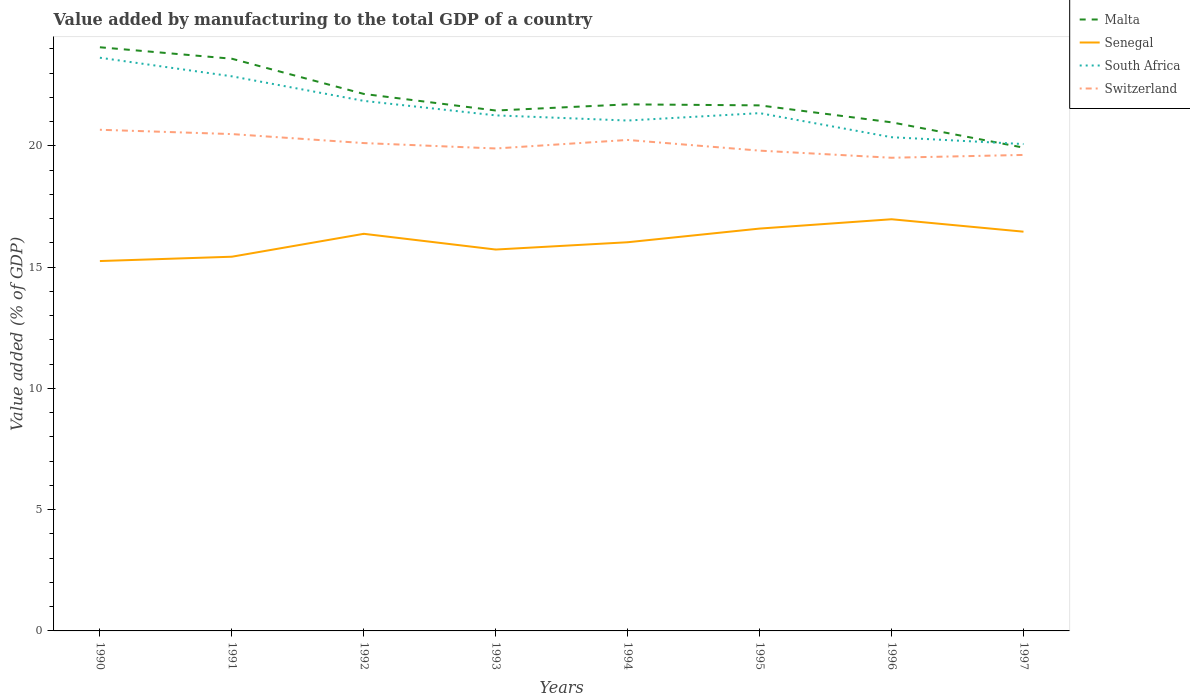How many different coloured lines are there?
Provide a short and direct response. 4. Does the line corresponding to Switzerland intersect with the line corresponding to Malta?
Provide a succinct answer. No. Is the number of lines equal to the number of legend labels?
Provide a succinct answer. Yes. Across all years, what is the maximum value added by manufacturing to the total GDP in Senegal?
Offer a very short reply. 15.25. What is the total value added by manufacturing to the total GDP in South Africa in the graph?
Your response must be concise. 1.01. What is the difference between the highest and the second highest value added by manufacturing to the total GDP in South Africa?
Offer a very short reply. 3.56. What is the difference between the highest and the lowest value added by manufacturing to the total GDP in Senegal?
Offer a very short reply. 4. How many lines are there?
Make the answer very short. 4. How many years are there in the graph?
Your answer should be compact. 8. What is the difference between two consecutive major ticks on the Y-axis?
Give a very brief answer. 5. Does the graph contain any zero values?
Provide a short and direct response. No. How are the legend labels stacked?
Your response must be concise. Vertical. What is the title of the graph?
Ensure brevity in your answer.  Value added by manufacturing to the total GDP of a country. What is the label or title of the Y-axis?
Provide a short and direct response. Value added (% of GDP). What is the Value added (% of GDP) of Malta in 1990?
Ensure brevity in your answer.  24.07. What is the Value added (% of GDP) in Senegal in 1990?
Offer a terse response. 15.25. What is the Value added (% of GDP) in South Africa in 1990?
Keep it short and to the point. 23.64. What is the Value added (% of GDP) of Switzerland in 1990?
Your answer should be compact. 20.67. What is the Value added (% of GDP) in Malta in 1991?
Your response must be concise. 23.6. What is the Value added (% of GDP) of Senegal in 1991?
Your answer should be compact. 15.43. What is the Value added (% of GDP) in South Africa in 1991?
Your answer should be very brief. 22.87. What is the Value added (% of GDP) in Switzerland in 1991?
Ensure brevity in your answer.  20.49. What is the Value added (% of GDP) of Malta in 1992?
Provide a succinct answer. 22.15. What is the Value added (% of GDP) of Senegal in 1992?
Your answer should be compact. 16.38. What is the Value added (% of GDP) of South Africa in 1992?
Your answer should be compact. 21.86. What is the Value added (% of GDP) in Switzerland in 1992?
Keep it short and to the point. 20.12. What is the Value added (% of GDP) of Malta in 1993?
Your answer should be very brief. 21.46. What is the Value added (% of GDP) of Senegal in 1993?
Provide a short and direct response. 15.73. What is the Value added (% of GDP) in South Africa in 1993?
Make the answer very short. 21.26. What is the Value added (% of GDP) of Switzerland in 1993?
Offer a very short reply. 19.9. What is the Value added (% of GDP) of Malta in 1994?
Offer a terse response. 21.72. What is the Value added (% of GDP) of Senegal in 1994?
Offer a very short reply. 16.03. What is the Value added (% of GDP) of South Africa in 1994?
Offer a terse response. 21.05. What is the Value added (% of GDP) in Switzerland in 1994?
Give a very brief answer. 20.25. What is the Value added (% of GDP) in Malta in 1995?
Provide a short and direct response. 21.67. What is the Value added (% of GDP) of Senegal in 1995?
Give a very brief answer. 16.59. What is the Value added (% of GDP) of South Africa in 1995?
Offer a very short reply. 21.35. What is the Value added (% of GDP) of Switzerland in 1995?
Offer a very short reply. 19.81. What is the Value added (% of GDP) of Malta in 1996?
Provide a succinct answer. 20.98. What is the Value added (% of GDP) in Senegal in 1996?
Your answer should be compact. 16.98. What is the Value added (% of GDP) of South Africa in 1996?
Your answer should be compact. 20.36. What is the Value added (% of GDP) of Switzerland in 1996?
Your answer should be compact. 19.51. What is the Value added (% of GDP) of Malta in 1997?
Your answer should be very brief. 19.93. What is the Value added (% of GDP) in Senegal in 1997?
Ensure brevity in your answer.  16.47. What is the Value added (% of GDP) in South Africa in 1997?
Give a very brief answer. 20.08. What is the Value added (% of GDP) in Switzerland in 1997?
Your answer should be very brief. 19.63. Across all years, what is the maximum Value added (% of GDP) in Malta?
Make the answer very short. 24.07. Across all years, what is the maximum Value added (% of GDP) in Senegal?
Your answer should be very brief. 16.98. Across all years, what is the maximum Value added (% of GDP) of South Africa?
Make the answer very short. 23.64. Across all years, what is the maximum Value added (% of GDP) of Switzerland?
Provide a succinct answer. 20.67. Across all years, what is the minimum Value added (% of GDP) in Malta?
Your response must be concise. 19.93. Across all years, what is the minimum Value added (% of GDP) of Senegal?
Your answer should be very brief. 15.25. Across all years, what is the minimum Value added (% of GDP) of South Africa?
Your response must be concise. 20.08. Across all years, what is the minimum Value added (% of GDP) in Switzerland?
Offer a very short reply. 19.51. What is the total Value added (% of GDP) of Malta in the graph?
Provide a succinct answer. 175.58. What is the total Value added (% of GDP) of Senegal in the graph?
Ensure brevity in your answer.  128.86. What is the total Value added (% of GDP) in South Africa in the graph?
Provide a succinct answer. 172.48. What is the total Value added (% of GDP) in Switzerland in the graph?
Ensure brevity in your answer.  160.38. What is the difference between the Value added (% of GDP) in Malta in 1990 and that in 1991?
Provide a short and direct response. 0.47. What is the difference between the Value added (% of GDP) of Senegal in 1990 and that in 1991?
Give a very brief answer. -0.18. What is the difference between the Value added (% of GDP) in South Africa in 1990 and that in 1991?
Give a very brief answer. 0.77. What is the difference between the Value added (% of GDP) of Switzerland in 1990 and that in 1991?
Keep it short and to the point. 0.18. What is the difference between the Value added (% of GDP) of Malta in 1990 and that in 1992?
Provide a succinct answer. 1.92. What is the difference between the Value added (% of GDP) of Senegal in 1990 and that in 1992?
Your answer should be compact. -1.12. What is the difference between the Value added (% of GDP) of South Africa in 1990 and that in 1992?
Your answer should be compact. 1.78. What is the difference between the Value added (% of GDP) of Switzerland in 1990 and that in 1992?
Offer a terse response. 0.55. What is the difference between the Value added (% of GDP) of Malta in 1990 and that in 1993?
Provide a succinct answer. 2.61. What is the difference between the Value added (% of GDP) of Senegal in 1990 and that in 1993?
Your answer should be very brief. -0.47. What is the difference between the Value added (% of GDP) of South Africa in 1990 and that in 1993?
Offer a terse response. 2.38. What is the difference between the Value added (% of GDP) in Switzerland in 1990 and that in 1993?
Offer a terse response. 0.77. What is the difference between the Value added (% of GDP) in Malta in 1990 and that in 1994?
Make the answer very short. 2.35. What is the difference between the Value added (% of GDP) in Senegal in 1990 and that in 1994?
Provide a succinct answer. -0.78. What is the difference between the Value added (% of GDP) of South Africa in 1990 and that in 1994?
Give a very brief answer. 2.59. What is the difference between the Value added (% of GDP) in Switzerland in 1990 and that in 1994?
Offer a very short reply. 0.42. What is the difference between the Value added (% of GDP) in Malta in 1990 and that in 1995?
Your answer should be compact. 2.4. What is the difference between the Value added (% of GDP) in Senegal in 1990 and that in 1995?
Your response must be concise. -1.34. What is the difference between the Value added (% of GDP) of South Africa in 1990 and that in 1995?
Make the answer very short. 2.29. What is the difference between the Value added (% of GDP) of Switzerland in 1990 and that in 1995?
Provide a succinct answer. 0.86. What is the difference between the Value added (% of GDP) of Malta in 1990 and that in 1996?
Offer a very short reply. 3.1. What is the difference between the Value added (% of GDP) in Senegal in 1990 and that in 1996?
Provide a short and direct response. -1.72. What is the difference between the Value added (% of GDP) in South Africa in 1990 and that in 1996?
Make the answer very short. 3.28. What is the difference between the Value added (% of GDP) in Switzerland in 1990 and that in 1996?
Provide a succinct answer. 1.15. What is the difference between the Value added (% of GDP) in Malta in 1990 and that in 1997?
Provide a succinct answer. 4.14. What is the difference between the Value added (% of GDP) in Senegal in 1990 and that in 1997?
Make the answer very short. -1.21. What is the difference between the Value added (% of GDP) of South Africa in 1990 and that in 1997?
Give a very brief answer. 3.56. What is the difference between the Value added (% of GDP) of Switzerland in 1990 and that in 1997?
Your answer should be compact. 1.04. What is the difference between the Value added (% of GDP) of Malta in 1991 and that in 1992?
Offer a very short reply. 1.45. What is the difference between the Value added (% of GDP) of Senegal in 1991 and that in 1992?
Your response must be concise. -0.94. What is the difference between the Value added (% of GDP) in South Africa in 1991 and that in 1992?
Your response must be concise. 1.01. What is the difference between the Value added (% of GDP) of Switzerland in 1991 and that in 1992?
Your answer should be compact. 0.37. What is the difference between the Value added (% of GDP) of Malta in 1991 and that in 1993?
Give a very brief answer. 2.14. What is the difference between the Value added (% of GDP) in Senegal in 1991 and that in 1993?
Ensure brevity in your answer.  -0.3. What is the difference between the Value added (% of GDP) of South Africa in 1991 and that in 1993?
Offer a terse response. 1.61. What is the difference between the Value added (% of GDP) in Switzerland in 1991 and that in 1993?
Ensure brevity in your answer.  0.59. What is the difference between the Value added (% of GDP) in Malta in 1991 and that in 1994?
Give a very brief answer. 1.88. What is the difference between the Value added (% of GDP) in Senegal in 1991 and that in 1994?
Provide a succinct answer. -0.6. What is the difference between the Value added (% of GDP) of South Africa in 1991 and that in 1994?
Ensure brevity in your answer.  1.82. What is the difference between the Value added (% of GDP) of Switzerland in 1991 and that in 1994?
Provide a succinct answer. 0.24. What is the difference between the Value added (% of GDP) of Malta in 1991 and that in 1995?
Make the answer very short. 1.92. What is the difference between the Value added (% of GDP) of Senegal in 1991 and that in 1995?
Give a very brief answer. -1.16. What is the difference between the Value added (% of GDP) in South Africa in 1991 and that in 1995?
Your answer should be compact. 1.52. What is the difference between the Value added (% of GDP) of Switzerland in 1991 and that in 1995?
Your answer should be compact. 0.68. What is the difference between the Value added (% of GDP) in Malta in 1991 and that in 1996?
Keep it short and to the point. 2.62. What is the difference between the Value added (% of GDP) of Senegal in 1991 and that in 1996?
Your answer should be very brief. -1.55. What is the difference between the Value added (% of GDP) in South Africa in 1991 and that in 1996?
Give a very brief answer. 2.51. What is the difference between the Value added (% of GDP) of Switzerland in 1991 and that in 1996?
Offer a very short reply. 0.98. What is the difference between the Value added (% of GDP) in Malta in 1991 and that in 1997?
Your answer should be compact. 3.67. What is the difference between the Value added (% of GDP) of Senegal in 1991 and that in 1997?
Make the answer very short. -1.03. What is the difference between the Value added (% of GDP) in South Africa in 1991 and that in 1997?
Provide a succinct answer. 2.79. What is the difference between the Value added (% of GDP) of Switzerland in 1991 and that in 1997?
Offer a very short reply. 0.86. What is the difference between the Value added (% of GDP) in Malta in 1992 and that in 1993?
Your answer should be compact. 0.68. What is the difference between the Value added (% of GDP) in Senegal in 1992 and that in 1993?
Your response must be concise. 0.65. What is the difference between the Value added (% of GDP) of South Africa in 1992 and that in 1993?
Provide a succinct answer. 0.6. What is the difference between the Value added (% of GDP) in Switzerland in 1992 and that in 1993?
Provide a short and direct response. 0.22. What is the difference between the Value added (% of GDP) of Malta in 1992 and that in 1994?
Provide a succinct answer. 0.43. What is the difference between the Value added (% of GDP) of Senegal in 1992 and that in 1994?
Your answer should be compact. 0.35. What is the difference between the Value added (% of GDP) in South Africa in 1992 and that in 1994?
Provide a succinct answer. 0.81. What is the difference between the Value added (% of GDP) of Switzerland in 1992 and that in 1994?
Your answer should be compact. -0.13. What is the difference between the Value added (% of GDP) of Malta in 1992 and that in 1995?
Your response must be concise. 0.47. What is the difference between the Value added (% of GDP) in Senegal in 1992 and that in 1995?
Keep it short and to the point. -0.22. What is the difference between the Value added (% of GDP) of South Africa in 1992 and that in 1995?
Keep it short and to the point. 0.51. What is the difference between the Value added (% of GDP) of Switzerland in 1992 and that in 1995?
Provide a succinct answer. 0.31. What is the difference between the Value added (% of GDP) of Malta in 1992 and that in 1996?
Provide a short and direct response. 1.17. What is the difference between the Value added (% of GDP) of Senegal in 1992 and that in 1996?
Give a very brief answer. -0.6. What is the difference between the Value added (% of GDP) of South Africa in 1992 and that in 1996?
Your answer should be compact. 1.5. What is the difference between the Value added (% of GDP) in Switzerland in 1992 and that in 1996?
Offer a very short reply. 0.61. What is the difference between the Value added (% of GDP) in Malta in 1992 and that in 1997?
Your answer should be very brief. 2.21. What is the difference between the Value added (% of GDP) in Senegal in 1992 and that in 1997?
Your answer should be very brief. -0.09. What is the difference between the Value added (% of GDP) in South Africa in 1992 and that in 1997?
Your answer should be very brief. 1.78. What is the difference between the Value added (% of GDP) in Switzerland in 1992 and that in 1997?
Provide a succinct answer. 0.49. What is the difference between the Value added (% of GDP) of Malta in 1993 and that in 1994?
Provide a short and direct response. -0.25. What is the difference between the Value added (% of GDP) in Senegal in 1993 and that in 1994?
Provide a short and direct response. -0.3. What is the difference between the Value added (% of GDP) of South Africa in 1993 and that in 1994?
Offer a terse response. 0.21. What is the difference between the Value added (% of GDP) of Switzerland in 1993 and that in 1994?
Give a very brief answer. -0.35. What is the difference between the Value added (% of GDP) of Malta in 1993 and that in 1995?
Ensure brevity in your answer.  -0.21. What is the difference between the Value added (% of GDP) in Senegal in 1993 and that in 1995?
Your answer should be compact. -0.86. What is the difference between the Value added (% of GDP) of South Africa in 1993 and that in 1995?
Your answer should be very brief. -0.09. What is the difference between the Value added (% of GDP) of Switzerland in 1993 and that in 1995?
Provide a short and direct response. 0.09. What is the difference between the Value added (% of GDP) in Malta in 1993 and that in 1996?
Provide a short and direct response. 0.49. What is the difference between the Value added (% of GDP) in Senegal in 1993 and that in 1996?
Your answer should be compact. -1.25. What is the difference between the Value added (% of GDP) of South Africa in 1993 and that in 1996?
Provide a succinct answer. 0.9. What is the difference between the Value added (% of GDP) in Switzerland in 1993 and that in 1996?
Provide a succinct answer. 0.38. What is the difference between the Value added (% of GDP) of Malta in 1993 and that in 1997?
Make the answer very short. 1.53. What is the difference between the Value added (% of GDP) in Senegal in 1993 and that in 1997?
Make the answer very short. -0.74. What is the difference between the Value added (% of GDP) of South Africa in 1993 and that in 1997?
Your answer should be very brief. 1.18. What is the difference between the Value added (% of GDP) in Switzerland in 1993 and that in 1997?
Keep it short and to the point. 0.27. What is the difference between the Value added (% of GDP) in Malta in 1994 and that in 1995?
Make the answer very short. 0.04. What is the difference between the Value added (% of GDP) of Senegal in 1994 and that in 1995?
Your answer should be compact. -0.56. What is the difference between the Value added (% of GDP) of South Africa in 1994 and that in 1995?
Offer a very short reply. -0.31. What is the difference between the Value added (% of GDP) in Switzerland in 1994 and that in 1995?
Offer a very short reply. 0.44. What is the difference between the Value added (% of GDP) of Malta in 1994 and that in 1996?
Your answer should be compact. 0.74. What is the difference between the Value added (% of GDP) in Senegal in 1994 and that in 1996?
Make the answer very short. -0.95. What is the difference between the Value added (% of GDP) in South Africa in 1994 and that in 1996?
Your answer should be very brief. 0.69. What is the difference between the Value added (% of GDP) of Switzerland in 1994 and that in 1996?
Offer a very short reply. 0.73. What is the difference between the Value added (% of GDP) in Malta in 1994 and that in 1997?
Give a very brief answer. 1.78. What is the difference between the Value added (% of GDP) in Senegal in 1994 and that in 1997?
Offer a very short reply. -0.44. What is the difference between the Value added (% of GDP) of South Africa in 1994 and that in 1997?
Your response must be concise. 0.97. What is the difference between the Value added (% of GDP) of Switzerland in 1994 and that in 1997?
Your answer should be very brief. 0.62. What is the difference between the Value added (% of GDP) of Malta in 1995 and that in 1996?
Offer a terse response. 0.7. What is the difference between the Value added (% of GDP) in Senegal in 1995 and that in 1996?
Your answer should be very brief. -0.38. What is the difference between the Value added (% of GDP) in South Africa in 1995 and that in 1996?
Provide a short and direct response. 0.99. What is the difference between the Value added (% of GDP) in Switzerland in 1995 and that in 1996?
Ensure brevity in your answer.  0.29. What is the difference between the Value added (% of GDP) in Malta in 1995 and that in 1997?
Your response must be concise. 1.74. What is the difference between the Value added (% of GDP) of Senegal in 1995 and that in 1997?
Make the answer very short. 0.13. What is the difference between the Value added (% of GDP) in South Africa in 1995 and that in 1997?
Offer a very short reply. 1.28. What is the difference between the Value added (% of GDP) of Switzerland in 1995 and that in 1997?
Offer a terse response. 0.18. What is the difference between the Value added (% of GDP) of Malta in 1996 and that in 1997?
Your answer should be very brief. 1.04. What is the difference between the Value added (% of GDP) in Senegal in 1996 and that in 1997?
Ensure brevity in your answer.  0.51. What is the difference between the Value added (% of GDP) in South Africa in 1996 and that in 1997?
Keep it short and to the point. 0.28. What is the difference between the Value added (% of GDP) in Switzerland in 1996 and that in 1997?
Make the answer very short. -0.12. What is the difference between the Value added (% of GDP) in Malta in 1990 and the Value added (% of GDP) in Senegal in 1991?
Offer a very short reply. 8.64. What is the difference between the Value added (% of GDP) in Malta in 1990 and the Value added (% of GDP) in South Africa in 1991?
Provide a short and direct response. 1.2. What is the difference between the Value added (% of GDP) in Malta in 1990 and the Value added (% of GDP) in Switzerland in 1991?
Ensure brevity in your answer.  3.58. What is the difference between the Value added (% of GDP) in Senegal in 1990 and the Value added (% of GDP) in South Africa in 1991?
Your answer should be compact. -7.62. What is the difference between the Value added (% of GDP) in Senegal in 1990 and the Value added (% of GDP) in Switzerland in 1991?
Your response must be concise. -5.24. What is the difference between the Value added (% of GDP) in South Africa in 1990 and the Value added (% of GDP) in Switzerland in 1991?
Offer a very short reply. 3.15. What is the difference between the Value added (% of GDP) in Malta in 1990 and the Value added (% of GDP) in Senegal in 1992?
Your answer should be compact. 7.69. What is the difference between the Value added (% of GDP) in Malta in 1990 and the Value added (% of GDP) in South Africa in 1992?
Provide a succinct answer. 2.21. What is the difference between the Value added (% of GDP) in Malta in 1990 and the Value added (% of GDP) in Switzerland in 1992?
Your answer should be very brief. 3.95. What is the difference between the Value added (% of GDP) of Senegal in 1990 and the Value added (% of GDP) of South Africa in 1992?
Keep it short and to the point. -6.61. What is the difference between the Value added (% of GDP) in Senegal in 1990 and the Value added (% of GDP) in Switzerland in 1992?
Your answer should be compact. -4.87. What is the difference between the Value added (% of GDP) in South Africa in 1990 and the Value added (% of GDP) in Switzerland in 1992?
Provide a succinct answer. 3.52. What is the difference between the Value added (% of GDP) of Malta in 1990 and the Value added (% of GDP) of Senegal in 1993?
Your answer should be compact. 8.34. What is the difference between the Value added (% of GDP) in Malta in 1990 and the Value added (% of GDP) in South Africa in 1993?
Make the answer very short. 2.81. What is the difference between the Value added (% of GDP) of Malta in 1990 and the Value added (% of GDP) of Switzerland in 1993?
Make the answer very short. 4.17. What is the difference between the Value added (% of GDP) of Senegal in 1990 and the Value added (% of GDP) of South Africa in 1993?
Offer a terse response. -6.01. What is the difference between the Value added (% of GDP) in Senegal in 1990 and the Value added (% of GDP) in Switzerland in 1993?
Ensure brevity in your answer.  -4.64. What is the difference between the Value added (% of GDP) in South Africa in 1990 and the Value added (% of GDP) in Switzerland in 1993?
Provide a succinct answer. 3.74. What is the difference between the Value added (% of GDP) in Malta in 1990 and the Value added (% of GDP) in Senegal in 1994?
Give a very brief answer. 8.04. What is the difference between the Value added (% of GDP) of Malta in 1990 and the Value added (% of GDP) of South Africa in 1994?
Your response must be concise. 3.02. What is the difference between the Value added (% of GDP) of Malta in 1990 and the Value added (% of GDP) of Switzerland in 1994?
Give a very brief answer. 3.82. What is the difference between the Value added (% of GDP) in Senegal in 1990 and the Value added (% of GDP) in South Africa in 1994?
Provide a succinct answer. -5.79. What is the difference between the Value added (% of GDP) in Senegal in 1990 and the Value added (% of GDP) in Switzerland in 1994?
Give a very brief answer. -4.99. What is the difference between the Value added (% of GDP) in South Africa in 1990 and the Value added (% of GDP) in Switzerland in 1994?
Offer a very short reply. 3.39. What is the difference between the Value added (% of GDP) in Malta in 1990 and the Value added (% of GDP) in Senegal in 1995?
Your answer should be very brief. 7.48. What is the difference between the Value added (% of GDP) in Malta in 1990 and the Value added (% of GDP) in South Africa in 1995?
Give a very brief answer. 2.72. What is the difference between the Value added (% of GDP) in Malta in 1990 and the Value added (% of GDP) in Switzerland in 1995?
Offer a terse response. 4.26. What is the difference between the Value added (% of GDP) in Senegal in 1990 and the Value added (% of GDP) in South Africa in 1995?
Give a very brief answer. -6.1. What is the difference between the Value added (% of GDP) in Senegal in 1990 and the Value added (% of GDP) in Switzerland in 1995?
Your response must be concise. -4.55. What is the difference between the Value added (% of GDP) of South Africa in 1990 and the Value added (% of GDP) of Switzerland in 1995?
Ensure brevity in your answer.  3.83. What is the difference between the Value added (% of GDP) in Malta in 1990 and the Value added (% of GDP) in Senegal in 1996?
Ensure brevity in your answer.  7.09. What is the difference between the Value added (% of GDP) in Malta in 1990 and the Value added (% of GDP) in South Africa in 1996?
Your answer should be very brief. 3.71. What is the difference between the Value added (% of GDP) in Malta in 1990 and the Value added (% of GDP) in Switzerland in 1996?
Offer a very short reply. 4.56. What is the difference between the Value added (% of GDP) of Senegal in 1990 and the Value added (% of GDP) of South Africa in 1996?
Give a very brief answer. -5.11. What is the difference between the Value added (% of GDP) of Senegal in 1990 and the Value added (% of GDP) of Switzerland in 1996?
Make the answer very short. -4.26. What is the difference between the Value added (% of GDP) in South Africa in 1990 and the Value added (% of GDP) in Switzerland in 1996?
Ensure brevity in your answer.  4.13. What is the difference between the Value added (% of GDP) of Malta in 1990 and the Value added (% of GDP) of Senegal in 1997?
Your response must be concise. 7.61. What is the difference between the Value added (% of GDP) in Malta in 1990 and the Value added (% of GDP) in South Africa in 1997?
Give a very brief answer. 3.99. What is the difference between the Value added (% of GDP) of Malta in 1990 and the Value added (% of GDP) of Switzerland in 1997?
Your response must be concise. 4.44. What is the difference between the Value added (% of GDP) in Senegal in 1990 and the Value added (% of GDP) in South Africa in 1997?
Ensure brevity in your answer.  -4.83. What is the difference between the Value added (% of GDP) in Senegal in 1990 and the Value added (% of GDP) in Switzerland in 1997?
Your answer should be compact. -4.38. What is the difference between the Value added (% of GDP) in South Africa in 1990 and the Value added (% of GDP) in Switzerland in 1997?
Ensure brevity in your answer.  4.01. What is the difference between the Value added (% of GDP) in Malta in 1991 and the Value added (% of GDP) in Senegal in 1992?
Provide a short and direct response. 7.22. What is the difference between the Value added (% of GDP) in Malta in 1991 and the Value added (% of GDP) in South Africa in 1992?
Your response must be concise. 1.74. What is the difference between the Value added (% of GDP) of Malta in 1991 and the Value added (% of GDP) of Switzerland in 1992?
Provide a short and direct response. 3.48. What is the difference between the Value added (% of GDP) of Senegal in 1991 and the Value added (% of GDP) of South Africa in 1992?
Give a very brief answer. -6.43. What is the difference between the Value added (% of GDP) of Senegal in 1991 and the Value added (% of GDP) of Switzerland in 1992?
Provide a succinct answer. -4.69. What is the difference between the Value added (% of GDP) in South Africa in 1991 and the Value added (% of GDP) in Switzerland in 1992?
Make the answer very short. 2.75. What is the difference between the Value added (% of GDP) in Malta in 1991 and the Value added (% of GDP) in Senegal in 1993?
Your answer should be compact. 7.87. What is the difference between the Value added (% of GDP) in Malta in 1991 and the Value added (% of GDP) in South Africa in 1993?
Offer a very short reply. 2.34. What is the difference between the Value added (% of GDP) of Malta in 1991 and the Value added (% of GDP) of Switzerland in 1993?
Make the answer very short. 3.7. What is the difference between the Value added (% of GDP) in Senegal in 1991 and the Value added (% of GDP) in South Africa in 1993?
Your response must be concise. -5.83. What is the difference between the Value added (% of GDP) of Senegal in 1991 and the Value added (% of GDP) of Switzerland in 1993?
Make the answer very short. -4.46. What is the difference between the Value added (% of GDP) of South Africa in 1991 and the Value added (% of GDP) of Switzerland in 1993?
Ensure brevity in your answer.  2.98. What is the difference between the Value added (% of GDP) in Malta in 1991 and the Value added (% of GDP) in Senegal in 1994?
Your answer should be compact. 7.57. What is the difference between the Value added (% of GDP) in Malta in 1991 and the Value added (% of GDP) in South Africa in 1994?
Keep it short and to the point. 2.55. What is the difference between the Value added (% of GDP) of Malta in 1991 and the Value added (% of GDP) of Switzerland in 1994?
Your answer should be compact. 3.35. What is the difference between the Value added (% of GDP) in Senegal in 1991 and the Value added (% of GDP) in South Africa in 1994?
Ensure brevity in your answer.  -5.62. What is the difference between the Value added (% of GDP) of Senegal in 1991 and the Value added (% of GDP) of Switzerland in 1994?
Offer a very short reply. -4.82. What is the difference between the Value added (% of GDP) of South Africa in 1991 and the Value added (% of GDP) of Switzerland in 1994?
Provide a succinct answer. 2.62. What is the difference between the Value added (% of GDP) in Malta in 1991 and the Value added (% of GDP) in Senegal in 1995?
Provide a succinct answer. 7.01. What is the difference between the Value added (% of GDP) of Malta in 1991 and the Value added (% of GDP) of South Africa in 1995?
Keep it short and to the point. 2.24. What is the difference between the Value added (% of GDP) in Malta in 1991 and the Value added (% of GDP) in Switzerland in 1995?
Provide a short and direct response. 3.79. What is the difference between the Value added (% of GDP) in Senegal in 1991 and the Value added (% of GDP) in South Africa in 1995?
Ensure brevity in your answer.  -5.92. What is the difference between the Value added (% of GDP) in Senegal in 1991 and the Value added (% of GDP) in Switzerland in 1995?
Your answer should be compact. -4.37. What is the difference between the Value added (% of GDP) of South Africa in 1991 and the Value added (% of GDP) of Switzerland in 1995?
Provide a short and direct response. 3.07. What is the difference between the Value added (% of GDP) in Malta in 1991 and the Value added (% of GDP) in Senegal in 1996?
Offer a terse response. 6.62. What is the difference between the Value added (% of GDP) of Malta in 1991 and the Value added (% of GDP) of South Africa in 1996?
Keep it short and to the point. 3.24. What is the difference between the Value added (% of GDP) in Malta in 1991 and the Value added (% of GDP) in Switzerland in 1996?
Ensure brevity in your answer.  4.08. What is the difference between the Value added (% of GDP) of Senegal in 1991 and the Value added (% of GDP) of South Africa in 1996?
Your answer should be very brief. -4.93. What is the difference between the Value added (% of GDP) of Senegal in 1991 and the Value added (% of GDP) of Switzerland in 1996?
Keep it short and to the point. -4.08. What is the difference between the Value added (% of GDP) in South Africa in 1991 and the Value added (% of GDP) in Switzerland in 1996?
Your response must be concise. 3.36. What is the difference between the Value added (% of GDP) of Malta in 1991 and the Value added (% of GDP) of Senegal in 1997?
Keep it short and to the point. 7.13. What is the difference between the Value added (% of GDP) in Malta in 1991 and the Value added (% of GDP) in South Africa in 1997?
Your answer should be compact. 3.52. What is the difference between the Value added (% of GDP) in Malta in 1991 and the Value added (% of GDP) in Switzerland in 1997?
Your answer should be very brief. 3.97. What is the difference between the Value added (% of GDP) of Senegal in 1991 and the Value added (% of GDP) of South Africa in 1997?
Your answer should be very brief. -4.65. What is the difference between the Value added (% of GDP) of Senegal in 1991 and the Value added (% of GDP) of Switzerland in 1997?
Keep it short and to the point. -4.2. What is the difference between the Value added (% of GDP) of South Africa in 1991 and the Value added (% of GDP) of Switzerland in 1997?
Your answer should be compact. 3.24. What is the difference between the Value added (% of GDP) in Malta in 1992 and the Value added (% of GDP) in Senegal in 1993?
Ensure brevity in your answer.  6.42. What is the difference between the Value added (% of GDP) in Malta in 1992 and the Value added (% of GDP) in South Africa in 1993?
Give a very brief answer. 0.88. What is the difference between the Value added (% of GDP) in Malta in 1992 and the Value added (% of GDP) in Switzerland in 1993?
Keep it short and to the point. 2.25. What is the difference between the Value added (% of GDP) in Senegal in 1992 and the Value added (% of GDP) in South Africa in 1993?
Provide a short and direct response. -4.88. What is the difference between the Value added (% of GDP) in Senegal in 1992 and the Value added (% of GDP) in Switzerland in 1993?
Offer a very short reply. -3.52. What is the difference between the Value added (% of GDP) in South Africa in 1992 and the Value added (% of GDP) in Switzerland in 1993?
Make the answer very short. 1.96. What is the difference between the Value added (% of GDP) in Malta in 1992 and the Value added (% of GDP) in Senegal in 1994?
Ensure brevity in your answer.  6.12. What is the difference between the Value added (% of GDP) of Malta in 1992 and the Value added (% of GDP) of South Africa in 1994?
Provide a succinct answer. 1.1. What is the difference between the Value added (% of GDP) in Malta in 1992 and the Value added (% of GDP) in Switzerland in 1994?
Your answer should be compact. 1.9. What is the difference between the Value added (% of GDP) in Senegal in 1992 and the Value added (% of GDP) in South Africa in 1994?
Your answer should be compact. -4.67. What is the difference between the Value added (% of GDP) of Senegal in 1992 and the Value added (% of GDP) of Switzerland in 1994?
Offer a very short reply. -3.87. What is the difference between the Value added (% of GDP) in South Africa in 1992 and the Value added (% of GDP) in Switzerland in 1994?
Make the answer very short. 1.61. What is the difference between the Value added (% of GDP) in Malta in 1992 and the Value added (% of GDP) in Senegal in 1995?
Your response must be concise. 5.55. What is the difference between the Value added (% of GDP) of Malta in 1992 and the Value added (% of GDP) of South Africa in 1995?
Provide a short and direct response. 0.79. What is the difference between the Value added (% of GDP) of Malta in 1992 and the Value added (% of GDP) of Switzerland in 1995?
Provide a succinct answer. 2.34. What is the difference between the Value added (% of GDP) in Senegal in 1992 and the Value added (% of GDP) in South Africa in 1995?
Make the answer very short. -4.98. What is the difference between the Value added (% of GDP) in Senegal in 1992 and the Value added (% of GDP) in Switzerland in 1995?
Ensure brevity in your answer.  -3.43. What is the difference between the Value added (% of GDP) of South Africa in 1992 and the Value added (% of GDP) of Switzerland in 1995?
Ensure brevity in your answer.  2.05. What is the difference between the Value added (% of GDP) in Malta in 1992 and the Value added (% of GDP) in Senegal in 1996?
Offer a terse response. 5.17. What is the difference between the Value added (% of GDP) of Malta in 1992 and the Value added (% of GDP) of South Africa in 1996?
Give a very brief answer. 1.79. What is the difference between the Value added (% of GDP) of Malta in 1992 and the Value added (% of GDP) of Switzerland in 1996?
Offer a terse response. 2.63. What is the difference between the Value added (% of GDP) in Senegal in 1992 and the Value added (% of GDP) in South Africa in 1996?
Provide a short and direct response. -3.98. What is the difference between the Value added (% of GDP) of Senegal in 1992 and the Value added (% of GDP) of Switzerland in 1996?
Offer a terse response. -3.14. What is the difference between the Value added (% of GDP) in South Africa in 1992 and the Value added (% of GDP) in Switzerland in 1996?
Your answer should be very brief. 2.35. What is the difference between the Value added (% of GDP) in Malta in 1992 and the Value added (% of GDP) in Senegal in 1997?
Provide a succinct answer. 5.68. What is the difference between the Value added (% of GDP) in Malta in 1992 and the Value added (% of GDP) in South Africa in 1997?
Offer a terse response. 2.07. What is the difference between the Value added (% of GDP) of Malta in 1992 and the Value added (% of GDP) of Switzerland in 1997?
Make the answer very short. 2.52. What is the difference between the Value added (% of GDP) in Senegal in 1992 and the Value added (% of GDP) in South Africa in 1997?
Give a very brief answer. -3.7. What is the difference between the Value added (% of GDP) of Senegal in 1992 and the Value added (% of GDP) of Switzerland in 1997?
Your response must be concise. -3.25. What is the difference between the Value added (% of GDP) of South Africa in 1992 and the Value added (% of GDP) of Switzerland in 1997?
Provide a succinct answer. 2.23. What is the difference between the Value added (% of GDP) in Malta in 1993 and the Value added (% of GDP) in Senegal in 1994?
Offer a terse response. 5.43. What is the difference between the Value added (% of GDP) of Malta in 1993 and the Value added (% of GDP) of South Africa in 1994?
Give a very brief answer. 0.41. What is the difference between the Value added (% of GDP) of Malta in 1993 and the Value added (% of GDP) of Switzerland in 1994?
Offer a very short reply. 1.21. What is the difference between the Value added (% of GDP) in Senegal in 1993 and the Value added (% of GDP) in South Africa in 1994?
Ensure brevity in your answer.  -5.32. What is the difference between the Value added (% of GDP) of Senegal in 1993 and the Value added (% of GDP) of Switzerland in 1994?
Provide a succinct answer. -4.52. What is the difference between the Value added (% of GDP) in South Africa in 1993 and the Value added (% of GDP) in Switzerland in 1994?
Keep it short and to the point. 1.01. What is the difference between the Value added (% of GDP) in Malta in 1993 and the Value added (% of GDP) in Senegal in 1995?
Ensure brevity in your answer.  4.87. What is the difference between the Value added (% of GDP) of Malta in 1993 and the Value added (% of GDP) of South Africa in 1995?
Give a very brief answer. 0.11. What is the difference between the Value added (% of GDP) in Malta in 1993 and the Value added (% of GDP) in Switzerland in 1995?
Offer a terse response. 1.65. What is the difference between the Value added (% of GDP) of Senegal in 1993 and the Value added (% of GDP) of South Africa in 1995?
Keep it short and to the point. -5.63. What is the difference between the Value added (% of GDP) in Senegal in 1993 and the Value added (% of GDP) in Switzerland in 1995?
Make the answer very short. -4.08. What is the difference between the Value added (% of GDP) of South Africa in 1993 and the Value added (% of GDP) of Switzerland in 1995?
Your answer should be compact. 1.45. What is the difference between the Value added (% of GDP) in Malta in 1993 and the Value added (% of GDP) in Senegal in 1996?
Your answer should be very brief. 4.48. What is the difference between the Value added (% of GDP) of Malta in 1993 and the Value added (% of GDP) of South Africa in 1996?
Your response must be concise. 1.1. What is the difference between the Value added (% of GDP) of Malta in 1993 and the Value added (% of GDP) of Switzerland in 1996?
Provide a short and direct response. 1.95. What is the difference between the Value added (% of GDP) of Senegal in 1993 and the Value added (% of GDP) of South Africa in 1996?
Your answer should be very brief. -4.63. What is the difference between the Value added (% of GDP) in Senegal in 1993 and the Value added (% of GDP) in Switzerland in 1996?
Your answer should be very brief. -3.79. What is the difference between the Value added (% of GDP) of South Africa in 1993 and the Value added (% of GDP) of Switzerland in 1996?
Offer a very short reply. 1.75. What is the difference between the Value added (% of GDP) of Malta in 1993 and the Value added (% of GDP) of Senegal in 1997?
Make the answer very short. 5. What is the difference between the Value added (% of GDP) of Malta in 1993 and the Value added (% of GDP) of South Africa in 1997?
Ensure brevity in your answer.  1.38. What is the difference between the Value added (% of GDP) in Malta in 1993 and the Value added (% of GDP) in Switzerland in 1997?
Make the answer very short. 1.83. What is the difference between the Value added (% of GDP) in Senegal in 1993 and the Value added (% of GDP) in South Africa in 1997?
Your response must be concise. -4.35. What is the difference between the Value added (% of GDP) in Senegal in 1993 and the Value added (% of GDP) in Switzerland in 1997?
Keep it short and to the point. -3.9. What is the difference between the Value added (% of GDP) in South Africa in 1993 and the Value added (% of GDP) in Switzerland in 1997?
Provide a short and direct response. 1.63. What is the difference between the Value added (% of GDP) in Malta in 1994 and the Value added (% of GDP) in Senegal in 1995?
Give a very brief answer. 5.12. What is the difference between the Value added (% of GDP) in Malta in 1994 and the Value added (% of GDP) in South Africa in 1995?
Provide a short and direct response. 0.36. What is the difference between the Value added (% of GDP) of Malta in 1994 and the Value added (% of GDP) of Switzerland in 1995?
Offer a very short reply. 1.91. What is the difference between the Value added (% of GDP) in Senegal in 1994 and the Value added (% of GDP) in South Africa in 1995?
Keep it short and to the point. -5.32. What is the difference between the Value added (% of GDP) in Senegal in 1994 and the Value added (% of GDP) in Switzerland in 1995?
Your response must be concise. -3.78. What is the difference between the Value added (% of GDP) in South Africa in 1994 and the Value added (% of GDP) in Switzerland in 1995?
Your answer should be compact. 1.24. What is the difference between the Value added (% of GDP) in Malta in 1994 and the Value added (% of GDP) in Senegal in 1996?
Offer a terse response. 4.74. What is the difference between the Value added (% of GDP) in Malta in 1994 and the Value added (% of GDP) in South Africa in 1996?
Ensure brevity in your answer.  1.36. What is the difference between the Value added (% of GDP) of Malta in 1994 and the Value added (% of GDP) of Switzerland in 1996?
Offer a very short reply. 2.2. What is the difference between the Value added (% of GDP) of Senegal in 1994 and the Value added (% of GDP) of South Africa in 1996?
Your answer should be compact. -4.33. What is the difference between the Value added (% of GDP) of Senegal in 1994 and the Value added (% of GDP) of Switzerland in 1996?
Your answer should be very brief. -3.48. What is the difference between the Value added (% of GDP) of South Africa in 1994 and the Value added (% of GDP) of Switzerland in 1996?
Ensure brevity in your answer.  1.53. What is the difference between the Value added (% of GDP) of Malta in 1994 and the Value added (% of GDP) of Senegal in 1997?
Keep it short and to the point. 5.25. What is the difference between the Value added (% of GDP) in Malta in 1994 and the Value added (% of GDP) in South Africa in 1997?
Your response must be concise. 1.64. What is the difference between the Value added (% of GDP) in Malta in 1994 and the Value added (% of GDP) in Switzerland in 1997?
Provide a short and direct response. 2.09. What is the difference between the Value added (% of GDP) in Senegal in 1994 and the Value added (% of GDP) in South Africa in 1997?
Offer a very short reply. -4.05. What is the difference between the Value added (% of GDP) of Senegal in 1994 and the Value added (% of GDP) of Switzerland in 1997?
Your response must be concise. -3.6. What is the difference between the Value added (% of GDP) in South Africa in 1994 and the Value added (% of GDP) in Switzerland in 1997?
Provide a short and direct response. 1.42. What is the difference between the Value added (% of GDP) in Malta in 1995 and the Value added (% of GDP) in Senegal in 1996?
Offer a terse response. 4.7. What is the difference between the Value added (% of GDP) in Malta in 1995 and the Value added (% of GDP) in South Africa in 1996?
Ensure brevity in your answer.  1.31. What is the difference between the Value added (% of GDP) of Malta in 1995 and the Value added (% of GDP) of Switzerland in 1996?
Provide a succinct answer. 2.16. What is the difference between the Value added (% of GDP) in Senegal in 1995 and the Value added (% of GDP) in South Africa in 1996?
Keep it short and to the point. -3.77. What is the difference between the Value added (% of GDP) of Senegal in 1995 and the Value added (% of GDP) of Switzerland in 1996?
Ensure brevity in your answer.  -2.92. What is the difference between the Value added (% of GDP) of South Africa in 1995 and the Value added (% of GDP) of Switzerland in 1996?
Offer a very short reply. 1.84. What is the difference between the Value added (% of GDP) in Malta in 1995 and the Value added (% of GDP) in Senegal in 1997?
Give a very brief answer. 5.21. What is the difference between the Value added (% of GDP) of Malta in 1995 and the Value added (% of GDP) of South Africa in 1997?
Ensure brevity in your answer.  1.6. What is the difference between the Value added (% of GDP) in Malta in 1995 and the Value added (% of GDP) in Switzerland in 1997?
Your response must be concise. 2.04. What is the difference between the Value added (% of GDP) of Senegal in 1995 and the Value added (% of GDP) of South Africa in 1997?
Offer a very short reply. -3.49. What is the difference between the Value added (% of GDP) of Senegal in 1995 and the Value added (% of GDP) of Switzerland in 1997?
Your answer should be compact. -3.04. What is the difference between the Value added (% of GDP) of South Africa in 1995 and the Value added (% of GDP) of Switzerland in 1997?
Your response must be concise. 1.72. What is the difference between the Value added (% of GDP) of Malta in 1996 and the Value added (% of GDP) of Senegal in 1997?
Offer a terse response. 4.51. What is the difference between the Value added (% of GDP) in Malta in 1996 and the Value added (% of GDP) in South Africa in 1997?
Provide a succinct answer. 0.9. What is the difference between the Value added (% of GDP) of Malta in 1996 and the Value added (% of GDP) of Switzerland in 1997?
Your answer should be compact. 1.34. What is the difference between the Value added (% of GDP) in Senegal in 1996 and the Value added (% of GDP) in South Africa in 1997?
Your answer should be compact. -3.1. What is the difference between the Value added (% of GDP) of Senegal in 1996 and the Value added (% of GDP) of Switzerland in 1997?
Your response must be concise. -2.65. What is the difference between the Value added (% of GDP) of South Africa in 1996 and the Value added (% of GDP) of Switzerland in 1997?
Your answer should be compact. 0.73. What is the average Value added (% of GDP) of Malta per year?
Provide a succinct answer. 21.95. What is the average Value added (% of GDP) of Senegal per year?
Offer a terse response. 16.11. What is the average Value added (% of GDP) in South Africa per year?
Your response must be concise. 21.56. What is the average Value added (% of GDP) in Switzerland per year?
Your answer should be compact. 20.05. In the year 1990, what is the difference between the Value added (% of GDP) of Malta and Value added (% of GDP) of Senegal?
Your answer should be very brief. 8.82. In the year 1990, what is the difference between the Value added (% of GDP) of Malta and Value added (% of GDP) of South Africa?
Offer a terse response. 0.43. In the year 1990, what is the difference between the Value added (% of GDP) of Malta and Value added (% of GDP) of Switzerland?
Offer a terse response. 3.4. In the year 1990, what is the difference between the Value added (% of GDP) in Senegal and Value added (% of GDP) in South Africa?
Provide a short and direct response. -8.39. In the year 1990, what is the difference between the Value added (% of GDP) of Senegal and Value added (% of GDP) of Switzerland?
Provide a succinct answer. -5.41. In the year 1990, what is the difference between the Value added (% of GDP) of South Africa and Value added (% of GDP) of Switzerland?
Ensure brevity in your answer.  2.97. In the year 1991, what is the difference between the Value added (% of GDP) of Malta and Value added (% of GDP) of Senegal?
Your answer should be compact. 8.17. In the year 1991, what is the difference between the Value added (% of GDP) of Malta and Value added (% of GDP) of South Africa?
Provide a short and direct response. 0.73. In the year 1991, what is the difference between the Value added (% of GDP) of Malta and Value added (% of GDP) of Switzerland?
Keep it short and to the point. 3.11. In the year 1991, what is the difference between the Value added (% of GDP) in Senegal and Value added (% of GDP) in South Africa?
Your answer should be compact. -7.44. In the year 1991, what is the difference between the Value added (% of GDP) of Senegal and Value added (% of GDP) of Switzerland?
Your answer should be compact. -5.06. In the year 1991, what is the difference between the Value added (% of GDP) of South Africa and Value added (% of GDP) of Switzerland?
Give a very brief answer. 2.38. In the year 1992, what is the difference between the Value added (% of GDP) in Malta and Value added (% of GDP) in Senegal?
Give a very brief answer. 5.77. In the year 1992, what is the difference between the Value added (% of GDP) in Malta and Value added (% of GDP) in South Africa?
Your response must be concise. 0.29. In the year 1992, what is the difference between the Value added (% of GDP) in Malta and Value added (% of GDP) in Switzerland?
Make the answer very short. 2.03. In the year 1992, what is the difference between the Value added (% of GDP) of Senegal and Value added (% of GDP) of South Africa?
Provide a succinct answer. -5.48. In the year 1992, what is the difference between the Value added (% of GDP) of Senegal and Value added (% of GDP) of Switzerland?
Your answer should be very brief. -3.74. In the year 1992, what is the difference between the Value added (% of GDP) in South Africa and Value added (% of GDP) in Switzerland?
Offer a terse response. 1.74. In the year 1993, what is the difference between the Value added (% of GDP) of Malta and Value added (% of GDP) of Senegal?
Keep it short and to the point. 5.73. In the year 1993, what is the difference between the Value added (% of GDP) of Malta and Value added (% of GDP) of South Africa?
Keep it short and to the point. 0.2. In the year 1993, what is the difference between the Value added (% of GDP) in Malta and Value added (% of GDP) in Switzerland?
Your response must be concise. 1.56. In the year 1993, what is the difference between the Value added (% of GDP) of Senegal and Value added (% of GDP) of South Africa?
Provide a short and direct response. -5.53. In the year 1993, what is the difference between the Value added (% of GDP) of Senegal and Value added (% of GDP) of Switzerland?
Give a very brief answer. -4.17. In the year 1993, what is the difference between the Value added (% of GDP) in South Africa and Value added (% of GDP) in Switzerland?
Your answer should be very brief. 1.37. In the year 1994, what is the difference between the Value added (% of GDP) in Malta and Value added (% of GDP) in Senegal?
Your answer should be compact. 5.69. In the year 1994, what is the difference between the Value added (% of GDP) of Malta and Value added (% of GDP) of South Africa?
Give a very brief answer. 0.67. In the year 1994, what is the difference between the Value added (% of GDP) in Malta and Value added (% of GDP) in Switzerland?
Keep it short and to the point. 1.47. In the year 1994, what is the difference between the Value added (% of GDP) of Senegal and Value added (% of GDP) of South Africa?
Offer a very short reply. -5.02. In the year 1994, what is the difference between the Value added (% of GDP) in Senegal and Value added (% of GDP) in Switzerland?
Your answer should be compact. -4.22. In the year 1994, what is the difference between the Value added (% of GDP) of South Africa and Value added (% of GDP) of Switzerland?
Your answer should be very brief. 0.8. In the year 1995, what is the difference between the Value added (% of GDP) of Malta and Value added (% of GDP) of Senegal?
Offer a very short reply. 5.08. In the year 1995, what is the difference between the Value added (% of GDP) of Malta and Value added (% of GDP) of South Africa?
Your response must be concise. 0.32. In the year 1995, what is the difference between the Value added (% of GDP) in Malta and Value added (% of GDP) in Switzerland?
Ensure brevity in your answer.  1.87. In the year 1995, what is the difference between the Value added (% of GDP) of Senegal and Value added (% of GDP) of South Africa?
Offer a very short reply. -4.76. In the year 1995, what is the difference between the Value added (% of GDP) of Senegal and Value added (% of GDP) of Switzerland?
Your response must be concise. -3.21. In the year 1995, what is the difference between the Value added (% of GDP) in South Africa and Value added (% of GDP) in Switzerland?
Offer a very short reply. 1.55. In the year 1996, what is the difference between the Value added (% of GDP) of Malta and Value added (% of GDP) of Senegal?
Your response must be concise. 4. In the year 1996, what is the difference between the Value added (% of GDP) in Malta and Value added (% of GDP) in South Africa?
Your answer should be compact. 0.61. In the year 1996, what is the difference between the Value added (% of GDP) in Malta and Value added (% of GDP) in Switzerland?
Give a very brief answer. 1.46. In the year 1996, what is the difference between the Value added (% of GDP) in Senegal and Value added (% of GDP) in South Africa?
Give a very brief answer. -3.38. In the year 1996, what is the difference between the Value added (% of GDP) of Senegal and Value added (% of GDP) of Switzerland?
Offer a very short reply. -2.54. In the year 1996, what is the difference between the Value added (% of GDP) in South Africa and Value added (% of GDP) in Switzerland?
Offer a very short reply. 0.85. In the year 1997, what is the difference between the Value added (% of GDP) of Malta and Value added (% of GDP) of Senegal?
Give a very brief answer. 3.47. In the year 1997, what is the difference between the Value added (% of GDP) in Malta and Value added (% of GDP) in South Africa?
Offer a terse response. -0.15. In the year 1997, what is the difference between the Value added (% of GDP) of Malta and Value added (% of GDP) of Switzerland?
Your answer should be compact. 0.3. In the year 1997, what is the difference between the Value added (% of GDP) of Senegal and Value added (% of GDP) of South Africa?
Your response must be concise. -3.61. In the year 1997, what is the difference between the Value added (% of GDP) in Senegal and Value added (% of GDP) in Switzerland?
Your answer should be compact. -3.17. In the year 1997, what is the difference between the Value added (% of GDP) in South Africa and Value added (% of GDP) in Switzerland?
Offer a terse response. 0.45. What is the ratio of the Value added (% of GDP) in Senegal in 1990 to that in 1991?
Offer a terse response. 0.99. What is the ratio of the Value added (% of GDP) in South Africa in 1990 to that in 1991?
Offer a very short reply. 1.03. What is the ratio of the Value added (% of GDP) in Switzerland in 1990 to that in 1991?
Offer a terse response. 1.01. What is the ratio of the Value added (% of GDP) of Malta in 1990 to that in 1992?
Keep it short and to the point. 1.09. What is the ratio of the Value added (% of GDP) in Senegal in 1990 to that in 1992?
Offer a terse response. 0.93. What is the ratio of the Value added (% of GDP) of South Africa in 1990 to that in 1992?
Make the answer very short. 1.08. What is the ratio of the Value added (% of GDP) of Switzerland in 1990 to that in 1992?
Offer a very short reply. 1.03. What is the ratio of the Value added (% of GDP) in Malta in 1990 to that in 1993?
Ensure brevity in your answer.  1.12. What is the ratio of the Value added (% of GDP) in Senegal in 1990 to that in 1993?
Offer a very short reply. 0.97. What is the ratio of the Value added (% of GDP) of South Africa in 1990 to that in 1993?
Offer a very short reply. 1.11. What is the ratio of the Value added (% of GDP) in Switzerland in 1990 to that in 1993?
Make the answer very short. 1.04. What is the ratio of the Value added (% of GDP) of Malta in 1990 to that in 1994?
Give a very brief answer. 1.11. What is the ratio of the Value added (% of GDP) of Senegal in 1990 to that in 1994?
Offer a terse response. 0.95. What is the ratio of the Value added (% of GDP) in South Africa in 1990 to that in 1994?
Provide a succinct answer. 1.12. What is the ratio of the Value added (% of GDP) of Switzerland in 1990 to that in 1994?
Provide a succinct answer. 1.02. What is the ratio of the Value added (% of GDP) in Malta in 1990 to that in 1995?
Your answer should be very brief. 1.11. What is the ratio of the Value added (% of GDP) in Senegal in 1990 to that in 1995?
Offer a terse response. 0.92. What is the ratio of the Value added (% of GDP) of South Africa in 1990 to that in 1995?
Offer a terse response. 1.11. What is the ratio of the Value added (% of GDP) in Switzerland in 1990 to that in 1995?
Provide a succinct answer. 1.04. What is the ratio of the Value added (% of GDP) of Malta in 1990 to that in 1996?
Your answer should be compact. 1.15. What is the ratio of the Value added (% of GDP) of Senegal in 1990 to that in 1996?
Keep it short and to the point. 0.9. What is the ratio of the Value added (% of GDP) of South Africa in 1990 to that in 1996?
Offer a very short reply. 1.16. What is the ratio of the Value added (% of GDP) in Switzerland in 1990 to that in 1996?
Offer a terse response. 1.06. What is the ratio of the Value added (% of GDP) of Malta in 1990 to that in 1997?
Make the answer very short. 1.21. What is the ratio of the Value added (% of GDP) in Senegal in 1990 to that in 1997?
Offer a very short reply. 0.93. What is the ratio of the Value added (% of GDP) of South Africa in 1990 to that in 1997?
Your answer should be very brief. 1.18. What is the ratio of the Value added (% of GDP) of Switzerland in 1990 to that in 1997?
Ensure brevity in your answer.  1.05. What is the ratio of the Value added (% of GDP) in Malta in 1991 to that in 1992?
Ensure brevity in your answer.  1.07. What is the ratio of the Value added (% of GDP) of Senegal in 1991 to that in 1992?
Give a very brief answer. 0.94. What is the ratio of the Value added (% of GDP) of South Africa in 1991 to that in 1992?
Your answer should be compact. 1.05. What is the ratio of the Value added (% of GDP) of Switzerland in 1991 to that in 1992?
Your answer should be very brief. 1.02. What is the ratio of the Value added (% of GDP) in Malta in 1991 to that in 1993?
Give a very brief answer. 1.1. What is the ratio of the Value added (% of GDP) of Senegal in 1991 to that in 1993?
Offer a very short reply. 0.98. What is the ratio of the Value added (% of GDP) in South Africa in 1991 to that in 1993?
Your answer should be very brief. 1.08. What is the ratio of the Value added (% of GDP) of Switzerland in 1991 to that in 1993?
Ensure brevity in your answer.  1.03. What is the ratio of the Value added (% of GDP) of Malta in 1991 to that in 1994?
Give a very brief answer. 1.09. What is the ratio of the Value added (% of GDP) of Senegal in 1991 to that in 1994?
Provide a succinct answer. 0.96. What is the ratio of the Value added (% of GDP) in South Africa in 1991 to that in 1994?
Provide a short and direct response. 1.09. What is the ratio of the Value added (% of GDP) of Switzerland in 1991 to that in 1994?
Provide a short and direct response. 1.01. What is the ratio of the Value added (% of GDP) in Malta in 1991 to that in 1995?
Offer a very short reply. 1.09. What is the ratio of the Value added (% of GDP) of Senegal in 1991 to that in 1995?
Your response must be concise. 0.93. What is the ratio of the Value added (% of GDP) of South Africa in 1991 to that in 1995?
Your answer should be compact. 1.07. What is the ratio of the Value added (% of GDP) of Switzerland in 1991 to that in 1995?
Your answer should be very brief. 1.03. What is the ratio of the Value added (% of GDP) in Malta in 1991 to that in 1996?
Offer a very short reply. 1.13. What is the ratio of the Value added (% of GDP) in Senegal in 1991 to that in 1996?
Offer a very short reply. 0.91. What is the ratio of the Value added (% of GDP) of South Africa in 1991 to that in 1996?
Provide a short and direct response. 1.12. What is the ratio of the Value added (% of GDP) in Malta in 1991 to that in 1997?
Make the answer very short. 1.18. What is the ratio of the Value added (% of GDP) of Senegal in 1991 to that in 1997?
Your response must be concise. 0.94. What is the ratio of the Value added (% of GDP) in South Africa in 1991 to that in 1997?
Your answer should be very brief. 1.14. What is the ratio of the Value added (% of GDP) of Switzerland in 1991 to that in 1997?
Offer a terse response. 1.04. What is the ratio of the Value added (% of GDP) in Malta in 1992 to that in 1993?
Ensure brevity in your answer.  1.03. What is the ratio of the Value added (% of GDP) in Senegal in 1992 to that in 1993?
Give a very brief answer. 1.04. What is the ratio of the Value added (% of GDP) of South Africa in 1992 to that in 1993?
Give a very brief answer. 1.03. What is the ratio of the Value added (% of GDP) of Switzerland in 1992 to that in 1993?
Make the answer very short. 1.01. What is the ratio of the Value added (% of GDP) of Malta in 1992 to that in 1994?
Your response must be concise. 1.02. What is the ratio of the Value added (% of GDP) in Senegal in 1992 to that in 1994?
Give a very brief answer. 1.02. What is the ratio of the Value added (% of GDP) of South Africa in 1992 to that in 1994?
Keep it short and to the point. 1.04. What is the ratio of the Value added (% of GDP) of Switzerland in 1992 to that in 1994?
Your answer should be very brief. 0.99. What is the ratio of the Value added (% of GDP) in Malta in 1992 to that in 1995?
Make the answer very short. 1.02. What is the ratio of the Value added (% of GDP) in Senegal in 1992 to that in 1995?
Ensure brevity in your answer.  0.99. What is the ratio of the Value added (% of GDP) of South Africa in 1992 to that in 1995?
Your response must be concise. 1.02. What is the ratio of the Value added (% of GDP) in Switzerland in 1992 to that in 1995?
Your answer should be compact. 1.02. What is the ratio of the Value added (% of GDP) in Malta in 1992 to that in 1996?
Your response must be concise. 1.06. What is the ratio of the Value added (% of GDP) in Senegal in 1992 to that in 1996?
Ensure brevity in your answer.  0.96. What is the ratio of the Value added (% of GDP) of South Africa in 1992 to that in 1996?
Your answer should be very brief. 1.07. What is the ratio of the Value added (% of GDP) in Switzerland in 1992 to that in 1996?
Your response must be concise. 1.03. What is the ratio of the Value added (% of GDP) in Senegal in 1992 to that in 1997?
Offer a terse response. 0.99. What is the ratio of the Value added (% of GDP) in South Africa in 1992 to that in 1997?
Make the answer very short. 1.09. What is the ratio of the Value added (% of GDP) in Switzerland in 1992 to that in 1997?
Give a very brief answer. 1.02. What is the ratio of the Value added (% of GDP) of Malta in 1993 to that in 1994?
Provide a short and direct response. 0.99. What is the ratio of the Value added (% of GDP) of Senegal in 1993 to that in 1994?
Your answer should be very brief. 0.98. What is the ratio of the Value added (% of GDP) in Switzerland in 1993 to that in 1994?
Your answer should be compact. 0.98. What is the ratio of the Value added (% of GDP) in Malta in 1993 to that in 1995?
Your answer should be compact. 0.99. What is the ratio of the Value added (% of GDP) of Senegal in 1993 to that in 1995?
Your answer should be compact. 0.95. What is the ratio of the Value added (% of GDP) of South Africa in 1993 to that in 1995?
Keep it short and to the point. 1. What is the ratio of the Value added (% of GDP) in Malta in 1993 to that in 1996?
Keep it short and to the point. 1.02. What is the ratio of the Value added (% of GDP) in Senegal in 1993 to that in 1996?
Your answer should be very brief. 0.93. What is the ratio of the Value added (% of GDP) in South Africa in 1993 to that in 1996?
Your response must be concise. 1.04. What is the ratio of the Value added (% of GDP) of Switzerland in 1993 to that in 1996?
Keep it short and to the point. 1.02. What is the ratio of the Value added (% of GDP) of Malta in 1993 to that in 1997?
Provide a succinct answer. 1.08. What is the ratio of the Value added (% of GDP) of Senegal in 1993 to that in 1997?
Make the answer very short. 0.96. What is the ratio of the Value added (% of GDP) of South Africa in 1993 to that in 1997?
Your answer should be very brief. 1.06. What is the ratio of the Value added (% of GDP) in Switzerland in 1993 to that in 1997?
Provide a succinct answer. 1.01. What is the ratio of the Value added (% of GDP) in South Africa in 1994 to that in 1995?
Your response must be concise. 0.99. What is the ratio of the Value added (% of GDP) in Switzerland in 1994 to that in 1995?
Provide a short and direct response. 1.02. What is the ratio of the Value added (% of GDP) of Malta in 1994 to that in 1996?
Give a very brief answer. 1.04. What is the ratio of the Value added (% of GDP) in Senegal in 1994 to that in 1996?
Provide a short and direct response. 0.94. What is the ratio of the Value added (% of GDP) in South Africa in 1994 to that in 1996?
Offer a very short reply. 1.03. What is the ratio of the Value added (% of GDP) of Switzerland in 1994 to that in 1996?
Provide a succinct answer. 1.04. What is the ratio of the Value added (% of GDP) of Malta in 1994 to that in 1997?
Offer a very short reply. 1.09. What is the ratio of the Value added (% of GDP) in Senegal in 1994 to that in 1997?
Give a very brief answer. 0.97. What is the ratio of the Value added (% of GDP) of South Africa in 1994 to that in 1997?
Your answer should be very brief. 1.05. What is the ratio of the Value added (% of GDP) of Switzerland in 1994 to that in 1997?
Your answer should be compact. 1.03. What is the ratio of the Value added (% of GDP) of Senegal in 1995 to that in 1996?
Keep it short and to the point. 0.98. What is the ratio of the Value added (% of GDP) of South Africa in 1995 to that in 1996?
Make the answer very short. 1.05. What is the ratio of the Value added (% of GDP) in Malta in 1995 to that in 1997?
Ensure brevity in your answer.  1.09. What is the ratio of the Value added (% of GDP) of South Africa in 1995 to that in 1997?
Provide a succinct answer. 1.06. What is the ratio of the Value added (% of GDP) of Malta in 1996 to that in 1997?
Give a very brief answer. 1.05. What is the ratio of the Value added (% of GDP) in Senegal in 1996 to that in 1997?
Provide a succinct answer. 1.03. What is the ratio of the Value added (% of GDP) in Switzerland in 1996 to that in 1997?
Make the answer very short. 0.99. What is the difference between the highest and the second highest Value added (% of GDP) of Malta?
Provide a short and direct response. 0.47. What is the difference between the highest and the second highest Value added (% of GDP) of Senegal?
Provide a succinct answer. 0.38. What is the difference between the highest and the second highest Value added (% of GDP) of South Africa?
Your response must be concise. 0.77. What is the difference between the highest and the second highest Value added (% of GDP) in Switzerland?
Your answer should be compact. 0.18. What is the difference between the highest and the lowest Value added (% of GDP) in Malta?
Keep it short and to the point. 4.14. What is the difference between the highest and the lowest Value added (% of GDP) of Senegal?
Offer a very short reply. 1.72. What is the difference between the highest and the lowest Value added (% of GDP) of South Africa?
Provide a succinct answer. 3.56. What is the difference between the highest and the lowest Value added (% of GDP) of Switzerland?
Offer a terse response. 1.15. 